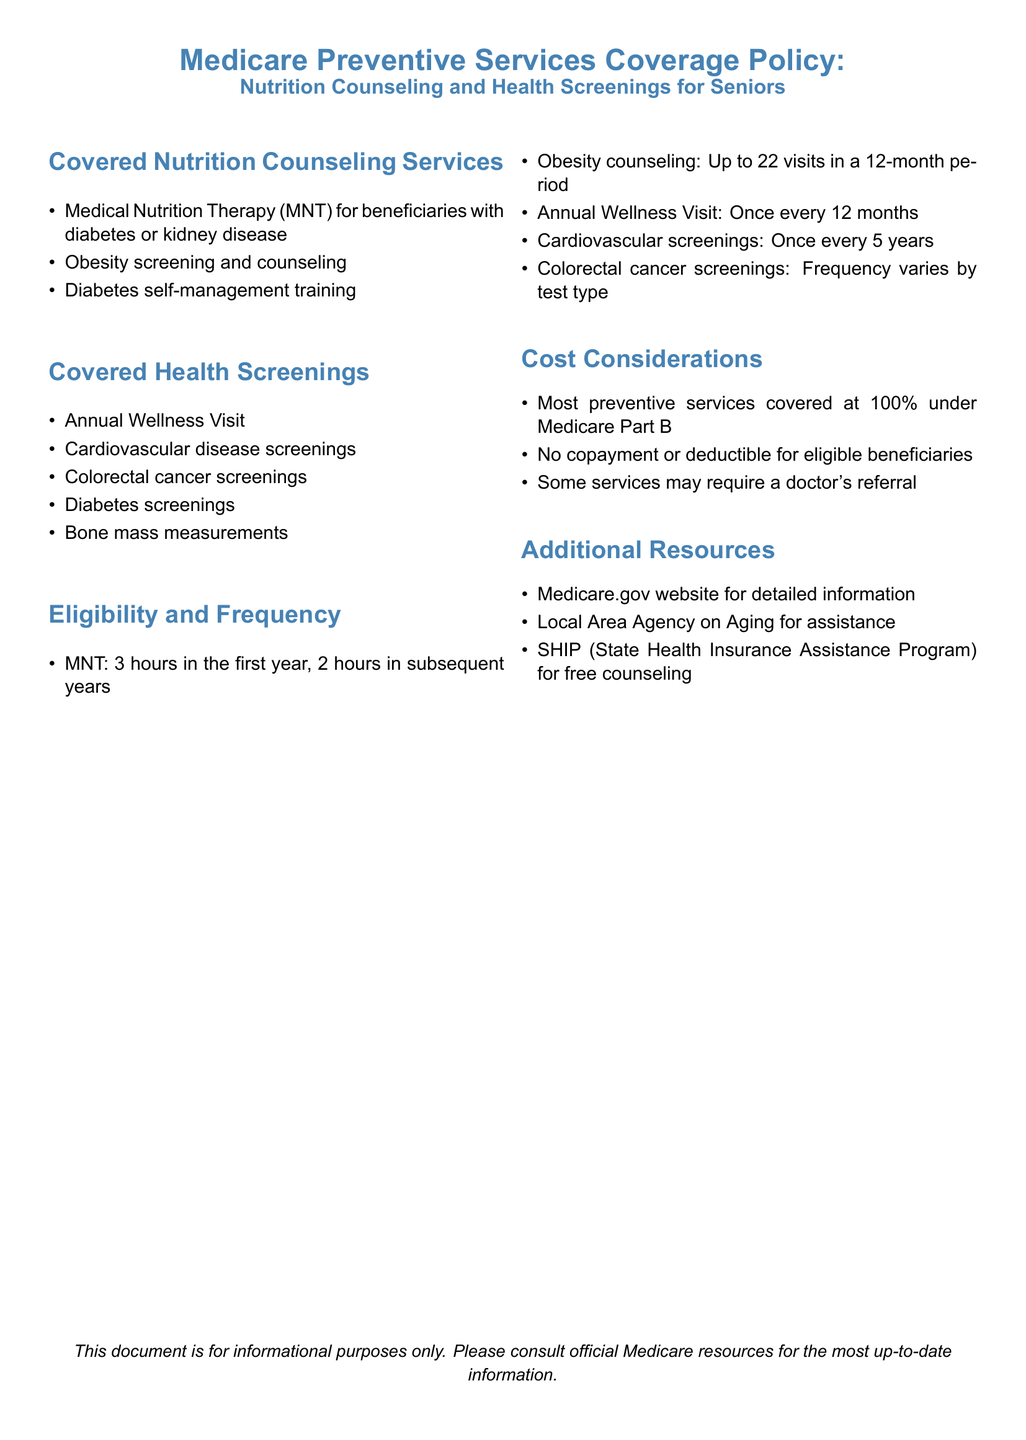What are the covered nutrition counseling services? The document lists specific services under "Covered Nutrition Counseling Services" such as Medical Nutrition Therapy, obesity screening, and diabetes self-management training.
Answer: Medical Nutrition Therapy, Obesity screening and counseling, Diabetes self-management training How many hours of Medical Nutrition Therapy are covered in the first year? The document specifies that 3 hours of Medical Nutrition Therapy are covered in the first year.
Answer: 3 hours How often can a beneficiary receive an Annual Wellness Visit? The document states that the Annual Wellness Visit can be received once every 12 months.
Answer: Once every 12 months What is the maximum number of obesity counseling visits allowed in a 12-month period? According to the eligibility section, beneficiaries can have up to 22 visits for obesity counseling in a year.
Answer: Up to 22 visits What is the coverage percentage for preventive services under Medicare Part B? The "Cost Considerations" section indicates most preventive services are covered at 100%.
Answer: 100% Which organization is mentioned for local assistance? The document lists the Local Area Agency on Aging as a contact for assistance.
Answer: Local Area Agency on Aging What are the cardiovascular screenings frequency? The eligible frequency for cardiovascular screenings is mentioned in the document as once every 5 years.
Answer: Once every 5 years What additional resource is available for free counseling? The document refers to the State Health Insurance Assistance Program (SHIP) as an additional resource for free counseling.
Answer: SHIP (State Health Insurance Assistance Program) 